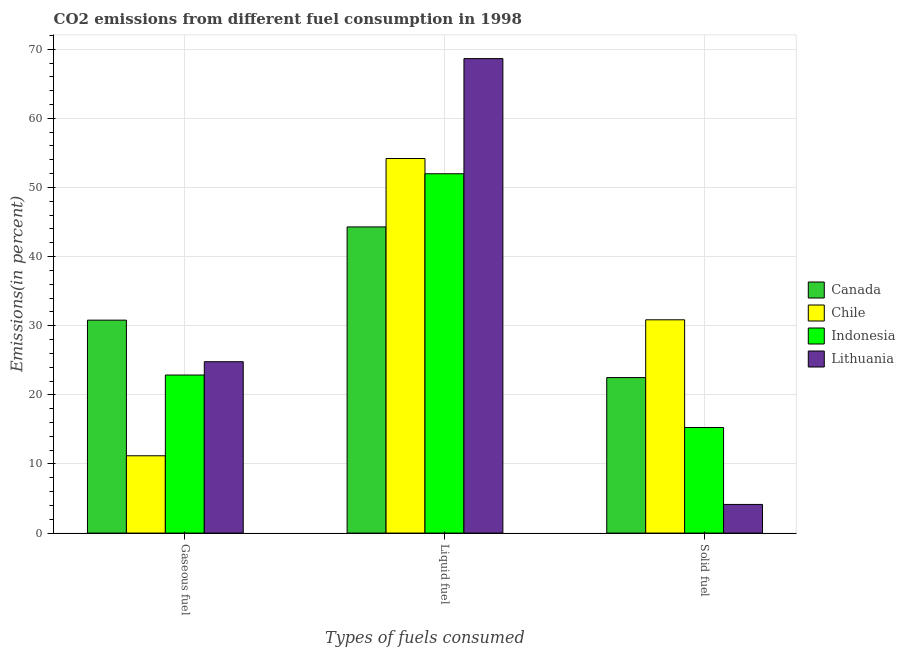How many groups of bars are there?
Your response must be concise. 3. Are the number of bars per tick equal to the number of legend labels?
Offer a very short reply. Yes. How many bars are there on the 2nd tick from the left?
Give a very brief answer. 4. What is the label of the 2nd group of bars from the left?
Your answer should be compact. Liquid fuel. What is the percentage of gaseous fuel emission in Chile?
Your response must be concise. 11.18. Across all countries, what is the maximum percentage of liquid fuel emission?
Make the answer very short. 68.64. Across all countries, what is the minimum percentage of gaseous fuel emission?
Offer a very short reply. 11.18. In which country was the percentage of liquid fuel emission maximum?
Offer a very short reply. Lithuania. In which country was the percentage of solid fuel emission minimum?
Make the answer very short. Lithuania. What is the total percentage of solid fuel emission in the graph?
Provide a short and direct response. 72.77. What is the difference between the percentage of liquid fuel emission in Canada and that in Indonesia?
Give a very brief answer. -7.69. What is the difference between the percentage of gaseous fuel emission in Lithuania and the percentage of liquid fuel emission in Indonesia?
Make the answer very short. -27.19. What is the average percentage of gaseous fuel emission per country?
Ensure brevity in your answer.  22.41. What is the difference between the percentage of liquid fuel emission and percentage of solid fuel emission in Lithuania?
Provide a short and direct response. 64.5. In how many countries, is the percentage of solid fuel emission greater than 2 %?
Give a very brief answer. 4. What is the ratio of the percentage of gaseous fuel emission in Indonesia to that in Canada?
Offer a very short reply. 0.74. What is the difference between the highest and the second highest percentage of solid fuel emission?
Your answer should be compact. 8.36. What is the difference between the highest and the lowest percentage of gaseous fuel emission?
Offer a terse response. 19.62. What does the 4th bar from the right in Solid fuel represents?
Provide a succinct answer. Canada. Are all the bars in the graph horizontal?
Your response must be concise. No. What is the difference between two consecutive major ticks on the Y-axis?
Your answer should be very brief. 10. Are the values on the major ticks of Y-axis written in scientific E-notation?
Your answer should be compact. No. Does the graph contain grids?
Offer a very short reply. Yes. How many legend labels are there?
Your answer should be very brief. 4. What is the title of the graph?
Your answer should be compact. CO2 emissions from different fuel consumption in 1998. What is the label or title of the X-axis?
Offer a very short reply. Types of fuels consumed. What is the label or title of the Y-axis?
Give a very brief answer. Emissions(in percent). What is the Emissions(in percent) of Canada in Gaseous fuel?
Offer a very short reply. 30.8. What is the Emissions(in percent) of Chile in Gaseous fuel?
Keep it short and to the point. 11.18. What is the Emissions(in percent) in Indonesia in Gaseous fuel?
Provide a short and direct response. 22.87. What is the Emissions(in percent) in Lithuania in Gaseous fuel?
Make the answer very short. 24.79. What is the Emissions(in percent) in Canada in Liquid fuel?
Make the answer very short. 44.29. What is the Emissions(in percent) of Chile in Liquid fuel?
Offer a terse response. 54.19. What is the Emissions(in percent) in Indonesia in Liquid fuel?
Provide a succinct answer. 51.98. What is the Emissions(in percent) of Lithuania in Liquid fuel?
Ensure brevity in your answer.  68.64. What is the Emissions(in percent) of Canada in Solid fuel?
Provide a short and direct response. 22.5. What is the Emissions(in percent) of Chile in Solid fuel?
Provide a short and direct response. 30.85. What is the Emissions(in percent) in Indonesia in Solid fuel?
Provide a short and direct response. 15.27. What is the Emissions(in percent) of Lithuania in Solid fuel?
Your response must be concise. 4.14. Across all Types of fuels consumed, what is the maximum Emissions(in percent) in Canada?
Ensure brevity in your answer.  44.29. Across all Types of fuels consumed, what is the maximum Emissions(in percent) of Chile?
Provide a short and direct response. 54.19. Across all Types of fuels consumed, what is the maximum Emissions(in percent) in Indonesia?
Ensure brevity in your answer.  51.98. Across all Types of fuels consumed, what is the maximum Emissions(in percent) of Lithuania?
Make the answer very short. 68.64. Across all Types of fuels consumed, what is the minimum Emissions(in percent) in Canada?
Your answer should be compact. 22.5. Across all Types of fuels consumed, what is the minimum Emissions(in percent) of Chile?
Your answer should be compact. 11.18. Across all Types of fuels consumed, what is the minimum Emissions(in percent) in Indonesia?
Your answer should be very brief. 15.27. Across all Types of fuels consumed, what is the minimum Emissions(in percent) in Lithuania?
Provide a short and direct response. 4.14. What is the total Emissions(in percent) of Canada in the graph?
Provide a succinct answer. 97.59. What is the total Emissions(in percent) of Chile in the graph?
Offer a very short reply. 96.23. What is the total Emissions(in percent) in Indonesia in the graph?
Provide a succinct answer. 90.12. What is the total Emissions(in percent) of Lithuania in the graph?
Offer a very short reply. 97.58. What is the difference between the Emissions(in percent) in Canada in Gaseous fuel and that in Liquid fuel?
Make the answer very short. -13.49. What is the difference between the Emissions(in percent) in Chile in Gaseous fuel and that in Liquid fuel?
Your answer should be compact. -43.01. What is the difference between the Emissions(in percent) of Indonesia in Gaseous fuel and that in Liquid fuel?
Provide a short and direct response. -29.12. What is the difference between the Emissions(in percent) of Lithuania in Gaseous fuel and that in Liquid fuel?
Keep it short and to the point. -43.85. What is the difference between the Emissions(in percent) of Canada in Gaseous fuel and that in Solid fuel?
Provide a succinct answer. 8.31. What is the difference between the Emissions(in percent) in Chile in Gaseous fuel and that in Solid fuel?
Keep it short and to the point. -19.67. What is the difference between the Emissions(in percent) of Indonesia in Gaseous fuel and that in Solid fuel?
Keep it short and to the point. 7.6. What is the difference between the Emissions(in percent) of Lithuania in Gaseous fuel and that in Solid fuel?
Your response must be concise. 20.65. What is the difference between the Emissions(in percent) of Canada in Liquid fuel and that in Solid fuel?
Keep it short and to the point. 21.8. What is the difference between the Emissions(in percent) of Chile in Liquid fuel and that in Solid fuel?
Your answer should be very brief. 23.33. What is the difference between the Emissions(in percent) in Indonesia in Liquid fuel and that in Solid fuel?
Give a very brief answer. 36.71. What is the difference between the Emissions(in percent) in Lithuania in Liquid fuel and that in Solid fuel?
Ensure brevity in your answer.  64.5. What is the difference between the Emissions(in percent) in Canada in Gaseous fuel and the Emissions(in percent) in Chile in Liquid fuel?
Your response must be concise. -23.38. What is the difference between the Emissions(in percent) of Canada in Gaseous fuel and the Emissions(in percent) of Indonesia in Liquid fuel?
Provide a short and direct response. -21.18. What is the difference between the Emissions(in percent) of Canada in Gaseous fuel and the Emissions(in percent) of Lithuania in Liquid fuel?
Give a very brief answer. -37.84. What is the difference between the Emissions(in percent) in Chile in Gaseous fuel and the Emissions(in percent) in Indonesia in Liquid fuel?
Provide a short and direct response. -40.8. What is the difference between the Emissions(in percent) in Chile in Gaseous fuel and the Emissions(in percent) in Lithuania in Liquid fuel?
Provide a succinct answer. -57.46. What is the difference between the Emissions(in percent) of Indonesia in Gaseous fuel and the Emissions(in percent) of Lithuania in Liquid fuel?
Keep it short and to the point. -45.78. What is the difference between the Emissions(in percent) of Canada in Gaseous fuel and the Emissions(in percent) of Chile in Solid fuel?
Offer a very short reply. -0.05. What is the difference between the Emissions(in percent) in Canada in Gaseous fuel and the Emissions(in percent) in Indonesia in Solid fuel?
Make the answer very short. 15.53. What is the difference between the Emissions(in percent) of Canada in Gaseous fuel and the Emissions(in percent) of Lithuania in Solid fuel?
Make the answer very short. 26.66. What is the difference between the Emissions(in percent) of Chile in Gaseous fuel and the Emissions(in percent) of Indonesia in Solid fuel?
Make the answer very short. -4.09. What is the difference between the Emissions(in percent) in Chile in Gaseous fuel and the Emissions(in percent) in Lithuania in Solid fuel?
Your answer should be compact. 7.04. What is the difference between the Emissions(in percent) of Indonesia in Gaseous fuel and the Emissions(in percent) of Lithuania in Solid fuel?
Your answer should be very brief. 18.72. What is the difference between the Emissions(in percent) in Canada in Liquid fuel and the Emissions(in percent) in Chile in Solid fuel?
Your response must be concise. 13.44. What is the difference between the Emissions(in percent) in Canada in Liquid fuel and the Emissions(in percent) in Indonesia in Solid fuel?
Ensure brevity in your answer.  29.02. What is the difference between the Emissions(in percent) in Canada in Liquid fuel and the Emissions(in percent) in Lithuania in Solid fuel?
Ensure brevity in your answer.  40.15. What is the difference between the Emissions(in percent) in Chile in Liquid fuel and the Emissions(in percent) in Indonesia in Solid fuel?
Ensure brevity in your answer.  38.92. What is the difference between the Emissions(in percent) of Chile in Liquid fuel and the Emissions(in percent) of Lithuania in Solid fuel?
Provide a short and direct response. 50.05. What is the difference between the Emissions(in percent) of Indonesia in Liquid fuel and the Emissions(in percent) of Lithuania in Solid fuel?
Your answer should be compact. 47.84. What is the average Emissions(in percent) in Canada per Types of fuels consumed?
Make the answer very short. 32.53. What is the average Emissions(in percent) of Chile per Types of fuels consumed?
Your response must be concise. 32.08. What is the average Emissions(in percent) in Indonesia per Types of fuels consumed?
Make the answer very short. 30.04. What is the average Emissions(in percent) in Lithuania per Types of fuels consumed?
Offer a terse response. 32.53. What is the difference between the Emissions(in percent) of Canada and Emissions(in percent) of Chile in Gaseous fuel?
Give a very brief answer. 19.62. What is the difference between the Emissions(in percent) in Canada and Emissions(in percent) in Indonesia in Gaseous fuel?
Offer a very short reply. 7.94. What is the difference between the Emissions(in percent) of Canada and Emissions(in percent) of Lithuania in Gaseous fuel?
Provide a succinct answer. 6.01. What is the difference between the Emissions(in percent) in Chile and Emissions(in percent) in Indonesia in Gaseous fuel?
Give a very brief answer. -11.68. What is the difference between the Emissions(in percent) of Chile and Emissions(in percent) of Lithuania in Gaseous fuel?
Keep it short and to the point. -13.61. What is the difference between the Emissions(in percent) in Indonesia and Emissions(in percent) in Lithuania in Gaseous fuel?
Keep it short and to the point. -1.92. What is the difference between the Emissions(in percent) of Canada and Emissions(in percent) of Chile in Liquid fuel?
Keep it short and to the point. -9.9. What is the difference between the Emissions(in percent) in Canada and Emissions(in percent) in Indonesia in Liquid fuel?
Provide a succinct answer. -7.69. What is the difference between the Emissions(in percent) in Canada and Emissions(in percent) in Lithuania in Liquid fuel?
Offer a terse response. -24.35. What is the difference between the Emissions(in percent) in Chile and Emissions(in percent) in Indonesia in Liquid fuel?
Give a very brief answer. 2.21. What is the difference between the Emissions(in percent) in Chile and Emissions(in percent) in Lithuania in Liquid fuel?
Provide a succinct answer. -14.45. What is the difference between the Emissions(in percent) of Indonesia and Emissions(in percent) of Lithuania in Liquid fuel?
Give a very brief answer. -16.66. What is the difference between the Emissions(in percent) of Canada and Emissions(in percent) of Chile in Solid fuel?
Provide a succinct answer. -8.36. What is the difference between the Emissions(in percent) in Canada and Emissions(in percent) in Indonesia in Solid fuel?
Give a very brief answer. 7.23. What is the difference between the Emissions(in percent) of Canada and Emissions(in percent) of Lithuania in Solid fuel?
Your answer should be compact. 18.35. What is the difference between the Emissions(in percent) in Chile and Emissions(in percent) in Indonesia in Solid fuel?
Your answer should be compact. 15.58. What is the difference between the Emissions(in percent) of Chile and Emissions(in percent) of Lithuania in Solid fuel?
Give a very brief answer. 26.71. What is the difference between the Emissions(in percent) in Indonesia and Emissions(in percent) in Lithuania in Solid fuel?
Give a very brief answer. 11.13. What is the ratio of the Emissions(in percent) in Canada in Gaseous fuel to that in Liquid fuel?
Offer a terse response. 0.7. What is the ratio of the Emissions(in percent) of Chile in Gaseous fuel to that in Liquid fuel?
Your response must be concise. 0.21. What is the ratio of the Emissions(in percent) in Indonesia in Gaseous fuel to that in Liquid fuel?
Offer a terse response. 0.44. What is the ratio of the Emissions(in percent) of Lithuania in Gaseous fuel to that in Liquid fuel?
Provide a short and direct response. 0.36. What is the ratio of the Emissions(in percent) of Canada in Gaseous fuel to that in Solid fuel?
Offer a terse response. 1.37. What is the ratio of the Emissions(in percent) in Chile in Gaseous fuel to that in Solid fuel?
Make the answer very short. 0.36. What is the ratio of the Emissions(in percent) in Indonesia in Gaseous fuel to that in Solid fuel?
Give a very brief answer. 1.5. What is the ratio of the Emissions(in percent) in Lithuania in Gaseous fuel to that in Solid fuel?
Offer a very short reply. 5.98. What is the ratio of the Emissions(in percent) in Canada in Liquid fuel to that in Solid fuel?
Make the answer very short. 1.97. What is the ratio of the Emissions(in percent) of Chile in Liquid fuel to that in Solid fuel?
Keep it short and to the point. 1.76. What is the ratio of the Emissions(in percent) in Indonesia in Liquid fuel to that in Solid fuel?
Provide a succinct answer. 3.4. What is the ratio of the Emissions(in percent) of Lithuania in Liquid fuel to that in Solid fuel?
Give a very brief answer. 16.57. What is the difference between the highest and the second highest Emissions(in percent) in Canada?
Provide a short and direct response. 13.49. What is the difference between the highest and the second highest Emissions(in percent) in Chile?
Your response must be concise. 23.33. What is the difference between the highest and the second highest Emissions(in percent) in Indonesia?
Your answer should be very brief. 29.12. What is the difference between the highest and the second highest Emissions(in percent) in Lithuania?
Ensure brevity in your answer.  43.85. What is the difference between the highest and the lowest Emissions(in percent) of Canada?
Your answer should be compact. 21.8. What is the difference between the highest and the lowest Emissions(in percent) in Chile?
Offer a terse response. 43.01. What is the difference between the highest and the lowest Emissions(in percent) of Indonesia?
Keep it short and to the point. 36.71. What is the difference between the highest and the lowest Emissions(in percent) of Lithuania?
Your response must be concise. 64.5. 